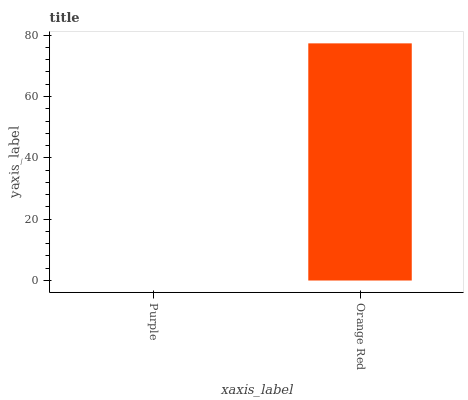Is Purple the minimum?
Answer yes or no. Yes. Is Orange Red the maximum?
Answer yes or no. Yes. Is Orange Red the minimum?
Answer yes or no. No. Is Orange Red greater than Purple?
Answer yes or no. Yes. Is Purple less than Orange Red?
Answer yes or no. Yes. Is Purple greater than Orange Red?
Answer yes or no. No. Is Orange Red less than Purple?
Answer yes or no. No. Is Orange Red the high median?
Answer yes or no. Yes. Is Purple the low median?
Answer yes or no. Yes. Is Purple the high median?
Answer yes or no. No. Is Orange Red the low median?
Answer yes or no. No. 